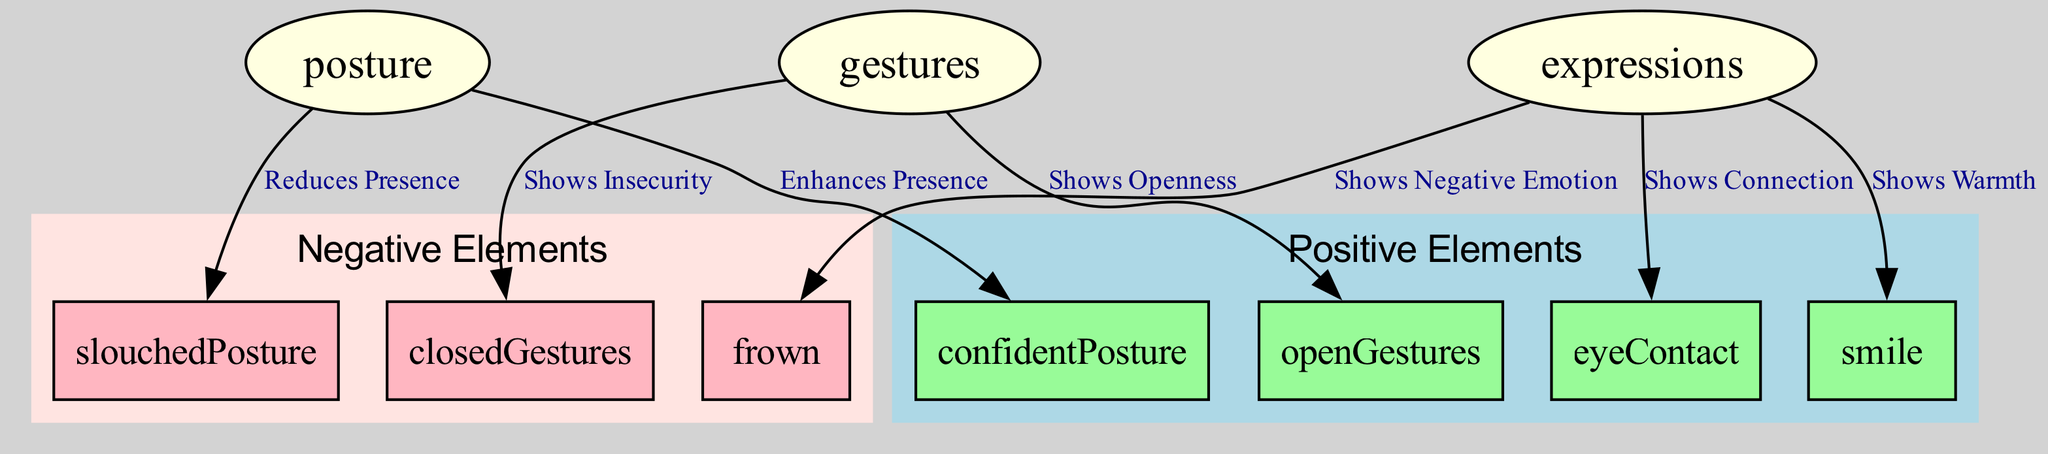What is the total number of nodes in the diagram? The diagram has a total of 10 nodes, which include posture, gestures, expressions, and their associated positive and negative elements.
Answer: 10 Which node enhances presence according to the diagram? The diagram states that "Confident Posture" enhances presence because it is directly connected to the posture node with that label.
Answer: Confident Posture What do open gestures show in the context of the diagram? The edge from gestures to open gestures is labeled "Shows Openness", indicating what they represent in the visual.
Answer: Openness How many negative elements are represented in the diagram? There are three negative elements indicated—slouched posture, closed gestures, and frown—highlighted in the negative elements cluster.
Answer: 3 Which facial expression indicates a connection? The diagram links eye contact to the expressions node with "Shows Connection", showing its role in establishing connection.
Answer: Eye Contact What type of gesture is associated with insecurity? The diagram connects closed gestures to the gestures node with the label "Shows Insecurity", reflecting their meaning.
Answer: Closed Gestures What is the main relationship between posture and slouched posture? Slouched posture is connected to the posture node with the label "Reduces Presence", indicating its negative effect on stage presence.
Answer: Reduces Presence Which element shows warmth according to the diagram? The edge from expressions to smile is labeled "Shows Warmth", pointing to it as the element that conveys warmth.
Answer: Smile Identify one positive element linked to gestures. The diagram connects gestures to open gestures with the label "Shows Openness", showing positivity in this relationship.
Answer: Open Gestures What does a frown represent in the context of expressions? The edge going from expressions to frown is labeled "Shows Negative Emotion," confirming its association with negativity.
Answer: Negative Emotion 